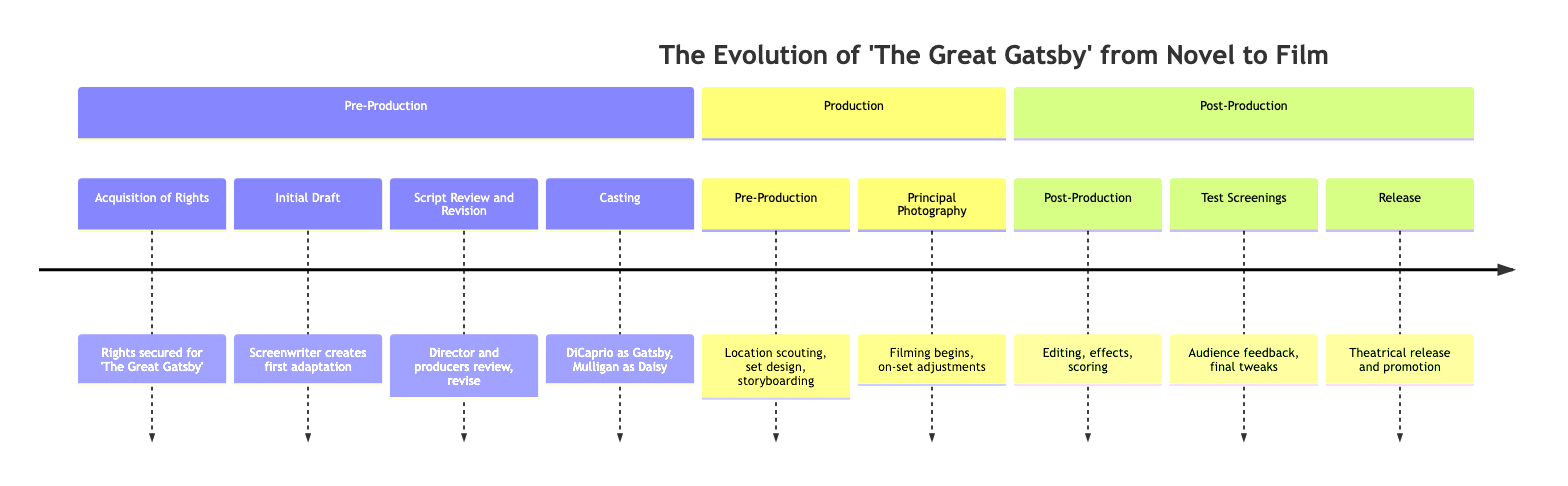What is the first milestone in the timeline? The first milestone listed in the timeline is "Acquisition of Rights," which is the first node within the "Pre-Production" section.
Answer: Acquisition of Rights How many milestones are in the timeline? By counting each milestone listed in the timeline, we find there are a total of 9 milestones, including those under "Pre-Production," "Production," and "Post-Production."
Answer: 9 Which actor was cast as Jay Gatsby? The diagram specifies that Leonardo DiCaprio was selected for the role of Jay Gatsby, making it the consistent information found in the "Casting" milestone.
Answer: Leonardo DiCaprio What occurs immediately after the Initial Draft? Following the "Initial Draft," the next milestone in the timeline is "Script Review and Revision," indicating this is the immediate next step in the process.
Answer: Script Review and Revision What section does "Post-Production" belong to? The milestone "Post-Production" can be located under the "Post-Production" section in the diagram, clearly labeled as such.
Answer: Post-Production What milestone involves audience feedback? The milestone that indicates audience feedback is "Test Screenings," which is explicitly mentioned in the "Post-Production" section.
Answer: Test Screenings Which milestone comes before "Principal Photography"? The milestone that comes before "Principal Photography" is "Pre-Production," indicating that planning and preparation occur prior to filming.
Answer: Pre-Production What is the final milestone of the adaptation process? According to the timeline, the last milestone in the adaptation process is "Release," marking the completion of the journey from novel to film.
Answer: Release What significant change happens during "Script Review and Revision"? During "Script Review and Revision," significant revisions are made to ensure the screenplay accurately reflects the novel while being suitable for film, highlighting the importance of this step.
Answer: Significant revisions made 